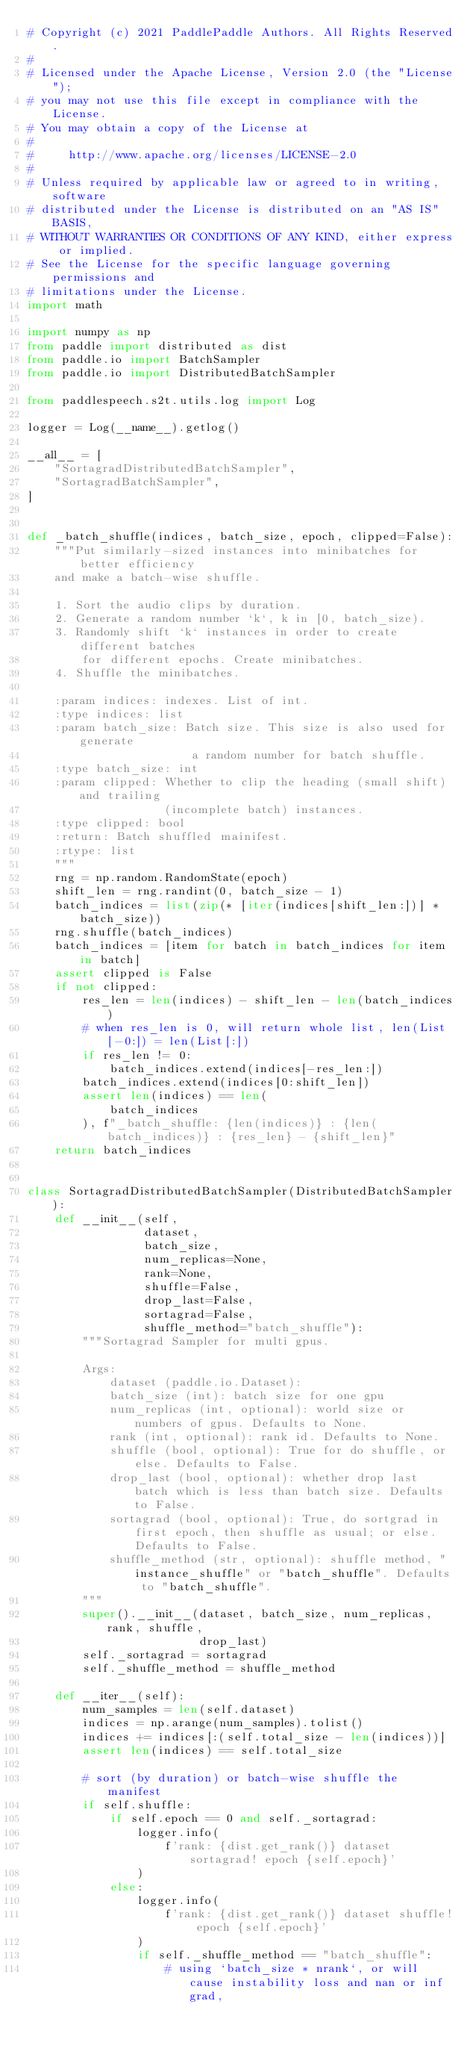<code> <loc_0><loc_0><loc_500><loc_500><_Python_># Copyright (c) 2021 PaddlePaddle Authors. All Rights Reserved.
#
# Licensed under the Apache License, Version 2.0 (the "License");
# you may not use this file except in compliance with the License.
# You may obtain a copy of the License at
#
#     http://www.apache.org/licenses/LICENSE-2.0
#
# Unless required by applicable law or agreed to in writing, software
# distributed under the License is distributed on an "AS IS" BASIS,
# WITHOUT WARRANTIES OR CONDITIONS OF ANY KIND, either express or implied.
# See the License for the specific language governing permissions and
# limitations under the License.
import math

import numpy as np
from paddle import distributed as dist
from paddle.io import BatchSampler
from paddle.io import DistributedBatchSampler

from paddlespeech.s2t.utils.log import Log

logger = Log(__name__).getlog()

__all__ = [
    "SortagradDistributedBatchSampler",
    "SortagradBatchSampler",
]


def _batch_shuffle(indices, batch_size, epoch, clipped=False):
    """Put similarly-sized instances into minibatches for better efficiency
    and make a batch-wise shuffle.

    1. Sort the audio clips by duration.
    2. Generate a random number `k`, k in [0, batch_size).
    3. Randomly shift `k` instances in order to create different batches
        for different epochs. Create minibatches.
    4. Shuffle the minibatches.

    :param indices: indexes. List of int.
    :type indices: list
    :param batch_size: Batch size. This size is also used for generate
                        a random number for batch shuffle.
    :type batch_size: int
    :param clipped: Whether to clip the heading (small shift) and trailing
                    (incomplete batch) instances.
    :type clipped: bool
    :return: Batch shuffled mainifest.
    :rtype: list
    """
    rng = np.random.RandomState(epoch)
    shift_len = rng.randint(0, batch_size - 1)
    batch_indices = list(zip(* [iter(indices[shift_len:])] * batch_size))
    rng.shuffle(batch_indices)
    batch_indices = [item for batch in batch_indices for item in batch]
    assert clipped is False
    if not clipped:
        res_len = len(indices) - shift_len - len(batch_indices)
        # when res_len is 0, will return whole list, len(List[-0:]) = len(List[:])
        if res_len != 0:
            batch_indices.extend(indices[-res_len:])
        batch_indices.extend(indices[0:shift_len])
        assert len(indices) == len(
            batch_indices
        ), f"_batch_shuffle: {len(indices)} : {len(batch_indices)} : {res_len} - {shift_len}"
    return batch_indices


class SortagradDistributedBatchSampler(DistributedBatchSampler):
    def __init__(self,
                 dataset,
                 batch_size,
                 num_replicas=None,
                 rank=None,
                 shuffle=False,
                 drop_last=False,
                 sortagrad=False,
                 shuffle_method="batch_shuffle"):
        """Sortagrad Sampler for multi gpus.

        Args:
            dataset (paddle.io.Dataset): 
            batch_size (int): batch size for one gpu
            num_replicas (int, optional): world size or numbers of gpus. Defaults to None.
            rank (int, optional): rank id. Defaults to None.
            shuffle (bool, optional): True for do shuffle, or else. Defaults to False.
            drop_last (bool, optional): whether drop last batch which is less than batch size. Defaults to False.
            sortagrad (bool, optional): True, do sortgrad in first epoch, then shuffle as usual; or else. Defaults to False.
            shuffle_method (str, optional): shuffle method, "instance_shuffle" or "batch_shuffle". Defaults to "batch_shuffle".
        """
        super().__init__(dataset, batch_size, num_replicas, rank, shuffle,
                         drop_last)
        self._sortagrad = sortagrad
        self._shuffle_method = shuffle_method

    def __iter__(self):
        num_samples = len(self.dataset)
        indices = np.arange(num_samples).tolist()
        indices += indices[:(self.total_size - len(indices))]
        assert len(indices) == self.total_size

        # sort (by duration) or batch-wise shuffle the manifest
        if self.shuffle:
            if self.epoch == 0 and self._sortagrad:
                logger.info(
                    f'rank: {dist.get_rank()} dataset sortagrad! epoch {self.epoch}'
                )
            else:
                logger.info(
                    f'rank: {dist.get_rank()} dataset shuffle! epoch {self.epoch}'
                )
                if self._shuffle_method == "batch_shuffle":
                    # using `batch_size * nrank`, or will cause instability loss and nan or inf grad, </code> 